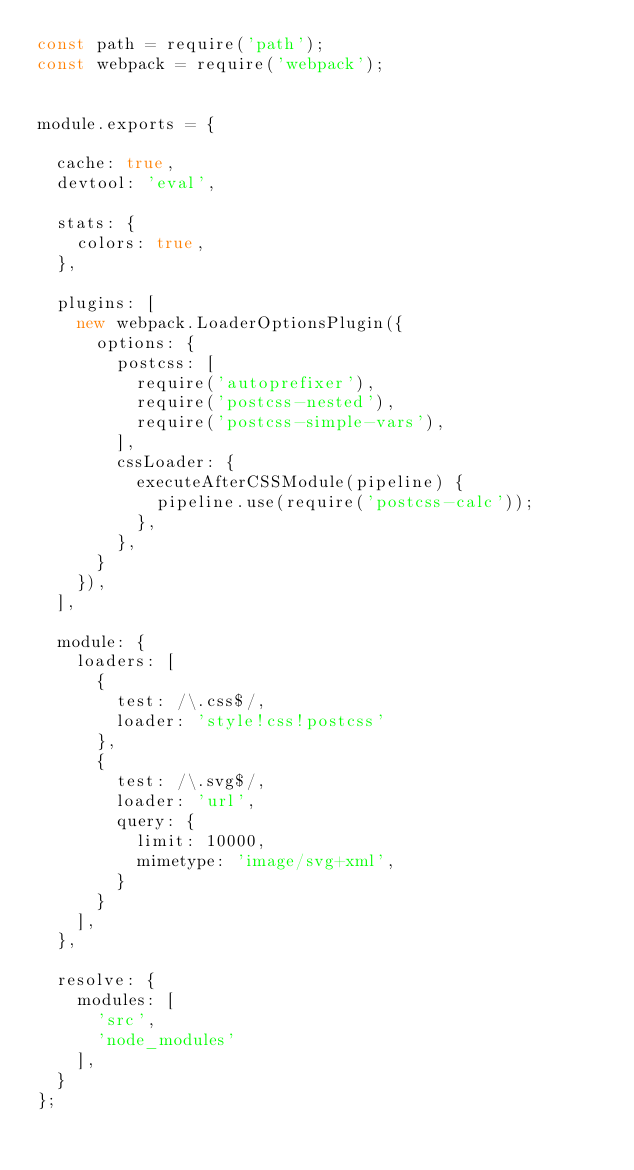<code> <loc_0><loc_0><loc_500><loc_500><_JavaScript_>const path = require('path');
const webpack = require('webpack');


module.exports = {

  cache: true,
  devtool: 'eval',

  stats: {
    colors: true,
  },

  plugins: [
    new webpack.LoaderOptionsPlugin({
      options: {
        postcss: [
          require('autoprefixer'),
          require('postcss-nested'),
          require('postcss-simple-vars'),
        ],
        cssLoader: {
          executeAfterCSSModule(pipeline) {
            pipeline.use(require('postcss-calc'));
          },
        },
      }
    }),
  ],

  module: {
    loaders: [
      {
        test: /\.css$/,
        loader: 'style!css!postcss'
      },
      {
        test: /\.svg$/,
        loader: 'url',
        query: {
          limit: 10000,
          mimetype: 'image/svg+xml',
        }
      }
    ],
  },

  resolve: {
    modules: [
      'src',
      'node_modules'
    ],
  }
};

</code> 